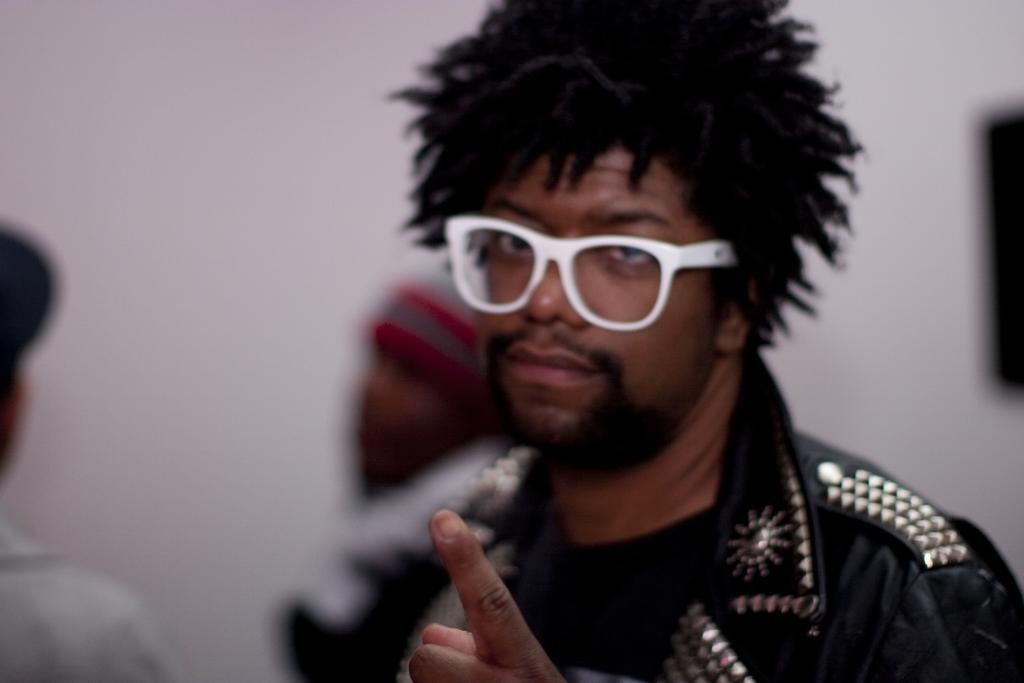What is the main subject of the image? There is a person in the image. What is the person wearing on their upper body? The person is wearing a black jacket. What type of eyewear is the person wearing? The person is wearing white-colored spectacles. Can you describe the background of the image? There are other persons visible in the background of the image, and there is a white-colored surface in the background. What type of force can be seen acting on the stone in the image? There is no stone present in the image, so it is not possible to determine if any force is acting on it. 